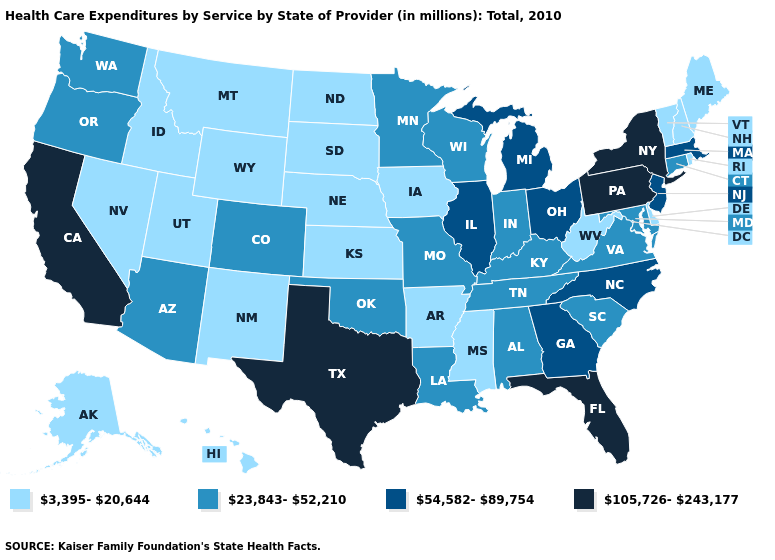Among the states that border Connecticut , does Rhode Island have the highest value?
Concise answer only. No. Which states have the highest value in the USA?
Keep it brief. California, Florida, New York, Pennsylvania, Texas. Name the states that have a value in the range 105,726-243,177?
Give a very brief answer. California, Florida, New York, Pennsylvania, Texas. Among the states that border Colorado , does Utah have the lowest value?
Answer briefly. Yes. What is the value of Alabama?
Be succinct. 23,843-52,210. Does Vermont have the lowest value in the Northeast?
Answer briefly. Yes. What is the value of Florida?
Give a very brief answer. 105,726-243,177. Does California have the highest value in the West?
Short answer required. Yes. What is the value of Tennessee?
Quick response, please. 23,843-52,210. What is the value of Nevada?
Concise answer only. 3,395-20,644. Name the states that have a value in the range 54,582-89,754?
Short answer required. Georgia, Illinois, Massachusetts, Michigan, New Jersey, North Carolina, Ohio. Does Montana have the lowest value in the West?
Answer briefly. Yes. Name the states that have a value in the range 3,395-20,644?
Quick response, please. Alaska, Arkansas, Delaware, Hawaii, Idaho, Iowa, Kansas, Maine, Mississippi, Montana, Nebraska, Nevada, New Hampshire, New Mexico, North Dakota, Rhode Island, South Dakota, Utah, Vermont, West Virginia, Wyoming. What is the value of Pennsylvania?
Answer briefly. 105,726-243,177. Among the states that border Indiana , does Illinois have the highest value?
Short answer required. Yes. 